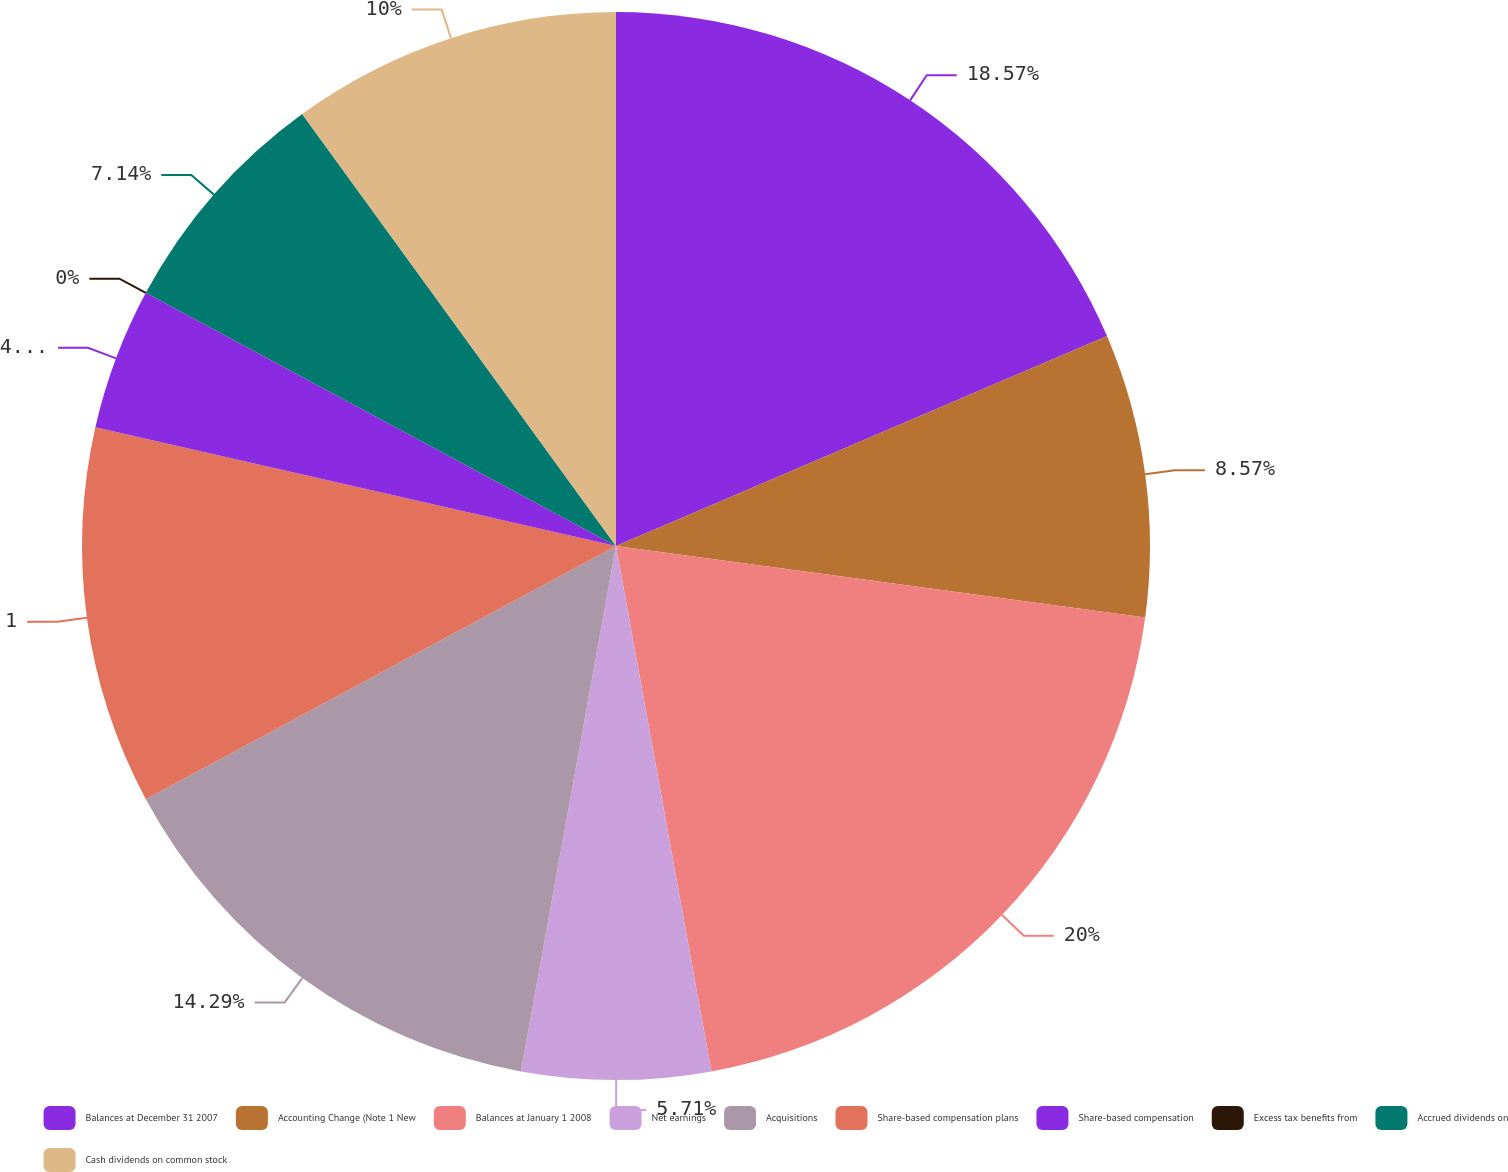Convert chart to OTSL. <chart><loc_0><loc_0><loc_500><loc_500><pie_chart><fcel>Balances at December 31 2007<fcel>Accounting Change (Note 1 New<fcel>Balances at January 1 2008<fcel>Net earnings<fcel>Acquisitions<fcel>Share-based compensation plans<fcel>Share-based compensation<fcel>Excess tax benefits from<fcel>Accrued dividends on<fcel>Cash dividends on common stock<nl><fcel>18.57%<fcel>8.57%<fcel>20.0%<fcel>5.71%<fcel>14.29%<fcel>11.43%<fcel>4.29%<fcel>0.0%<fcel>7.14%<fcel>10.0%<nl></chart> 